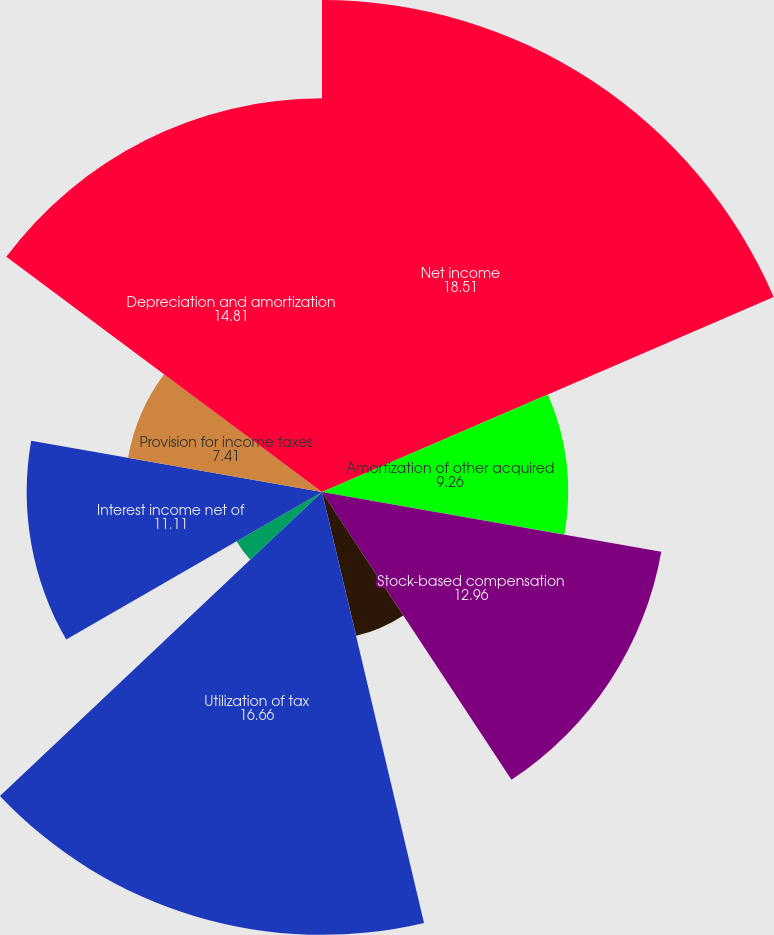Convert chart. <chart><loc_0><loc_0><loc_500><loc_500><pie_chart><fcel>Net income<fcel>Amortization of other acquired<fcel>Stock-based compensation<fcel>Amortization of capitalized<fcel>(Gain) loss on investments net<fcel>Utilization of tax<fcel>Restructuring charge (benefit)<fcel>Interest income net of<fcel>Provision for income taxes<fcel>Depreciation and amortization<nl><fcel>18.51%<fcel>9.26%<fcel>12.96%<fcel>5.56%<fcel>0.01%<fcel>16.66%<fcel>3.71%<fcel>11.11%<fcel>7.41%<fcel>14.81%<nl></chart> 